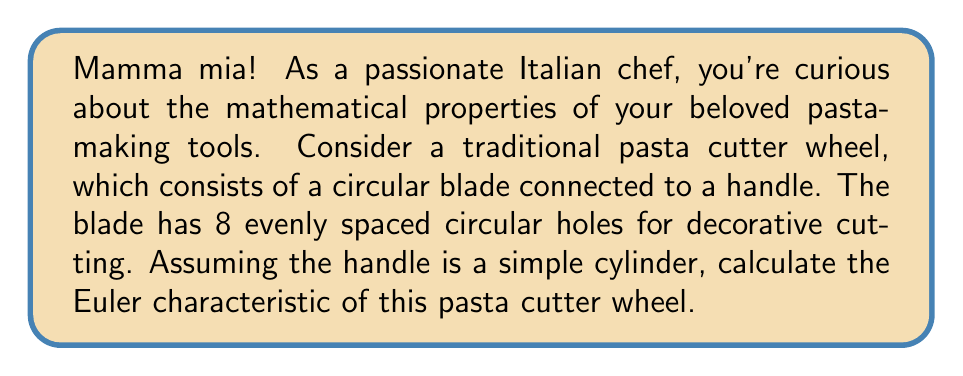Show me your answer to this math problem. Let's approach this step-by-step using the Euler characteristic formula:

$$\chi = V - E + F$$

Where $\chi$ is the Euler characteristic, $V$ is the number of vertices, $E$ is the number of edges, and $F$ is the number of faces.

1) First, let's consider the circular blade:
   - It has 8 circular holes, each contributing 1 face
   - The outer circle contributes 2 faces (front and back)
   - Total faces from the blade: $8 + 2 = 10$

2) The handle (cylinder) contributes:
   - 2 circular faces (top and bottom)
   - 1 curved face (the side of the cylinder)
   - Total faces from the handle: $3$

3) The connection between the handle and the blade doesn't introduce new faces.

4) Total number of faces: $F = 10 + 3 = 13$

5) For a topologically equivalent object, we can consider:
   - The outer circle of the blade and the cylinder form a torus
   - Each hole in the blade is equivalent to a handle attached to this torus

6) The Euler characteristic of a torus is 0.

7) Each handle (hole) decreases the Euler characteristic by 2.

Therefore, the Euler characteristic can be calculated as:

$$\chi = 0 - (8 \times 2) = -16$$

We can verify this using the formula $\chi = 2 - 2g$, where $g$ is the genus (number of holes or handles). In this case, $g = 9$ (8 holes in the blade plus the hole in the torus), so:

$$\chi = 2 - 2(9) = 2 - 18 = -16$$

This matches our previous calculation.
Answer: $\chi = -16$ 